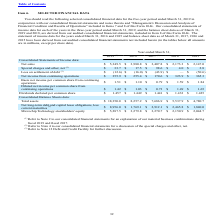From Microchip Technology's financial document, Which years does the table provide information for the company's consolidated balance sheets? The document contains multiple relevant values: 2019, 2018, 2017, 2016, 2015. From the document: "2019 (1) 2018 2017 (1) 2016 2015 2019 (1) 2018 2017 (1) 2016 2015 2019 (1) 2018 2017 (1) 2016 2015 2019 (1) 2018 2017 (1) 2016 2015 2019 (1) 2018 2017..." Also, What were the net sales in 2016? According to the financial document, 2,173.3 (in millions). The relevant text states: "Net sales $ 5,349.5 $ 3,980.8 $ 3,407.8 $ 2,173.3 $ 2,147.0..." Also, What was the loss on settlement of debt in 2019? According to the financial document, (12.6) (in millions). The relevant text states: "Loss on settlement of debt (3) $ (12.6) $ (16.0) $ (43.9) $ — $ (50.6)..." Also, can you calculate: What was the change in net sales between 2016 and 2017? Based on the calculation: 3,407.8-2,173.3, the result is 1234.5 (in millions). This is based on the information: "Net sales $ 5,349.5 $ 3,980.8 $ 3,407.8 $ 2,173.3 $ 2,147.0 Net sales $ 5,349.5 $ 3,980.8 $ 3,407.8 $ 2,173.3 $ 2,147.0..." The key data points involved are: 2,173.3, 3,407.8. Also, How many years did Total Assets exceed $10,000 million? Based on the analysis, there are 1 instances. The counting process: 2019. Also, can you calculate: What was the percentage change in the Net income from continuing operations between 2018 and 2019? To answer this question, I need to perform calculations using the financial data. The calculation is: (355.9-255.4)/255.4, which equals 39.35 (percentage). This is based on the information: "Net income from continuing operations $ 355.9 $ 255.4 $ 170.6 $ 323.9 $ 365.3 Net income from continuing operations $ 355.9 $ 255.4 $ 170.6 $ 323.9 $ 365.3..." The key data points involved are: 255.4, 355.9. 